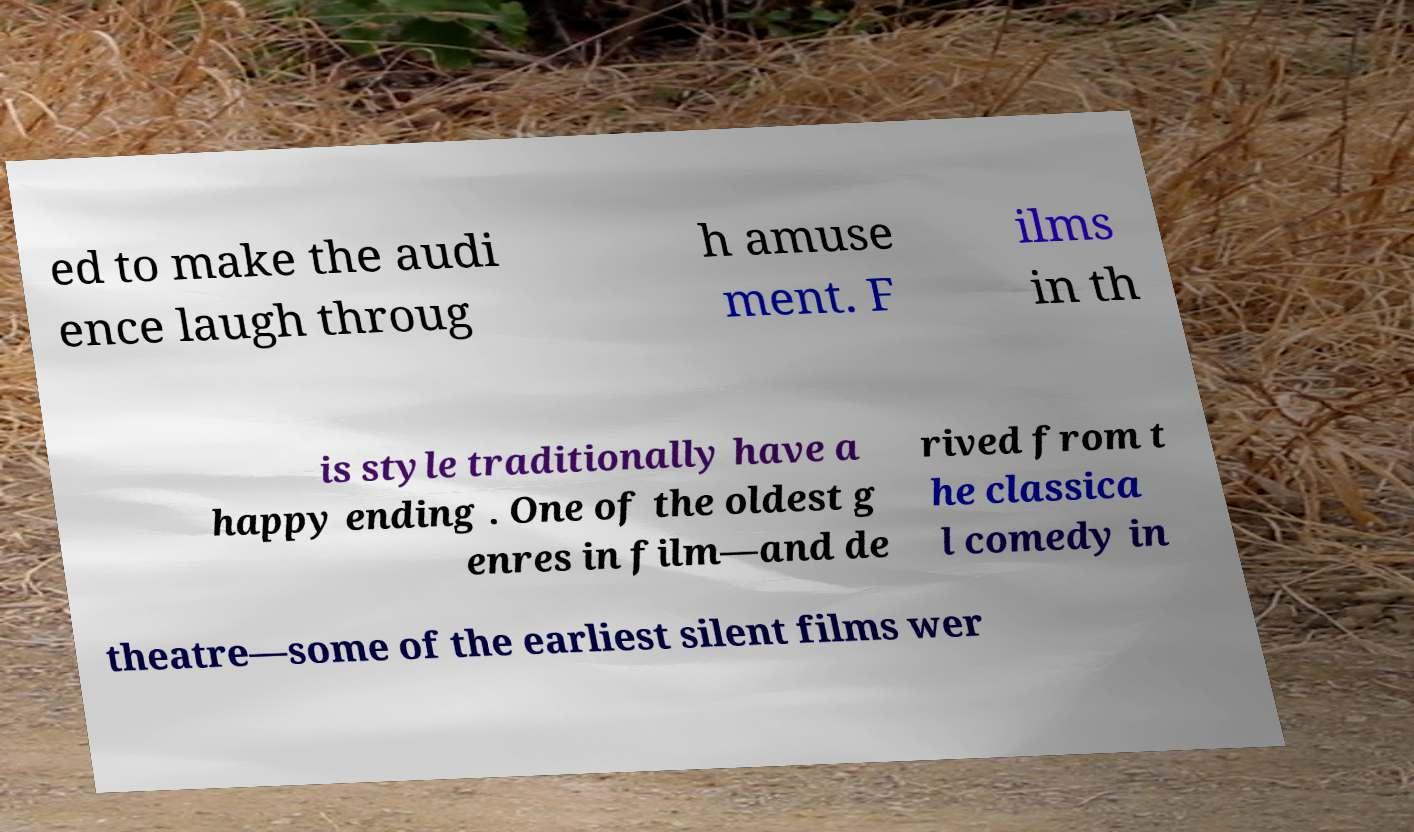Can you accurately transcribe the text from the provided image for me? ed to make the audi ence laugh throug h amuse ment. F ilms in th is style traditionally have a happy ending . One of the oldest g enres in film—and de rived from t he classica l comedy in theatre—some of the earliest silent films wer 